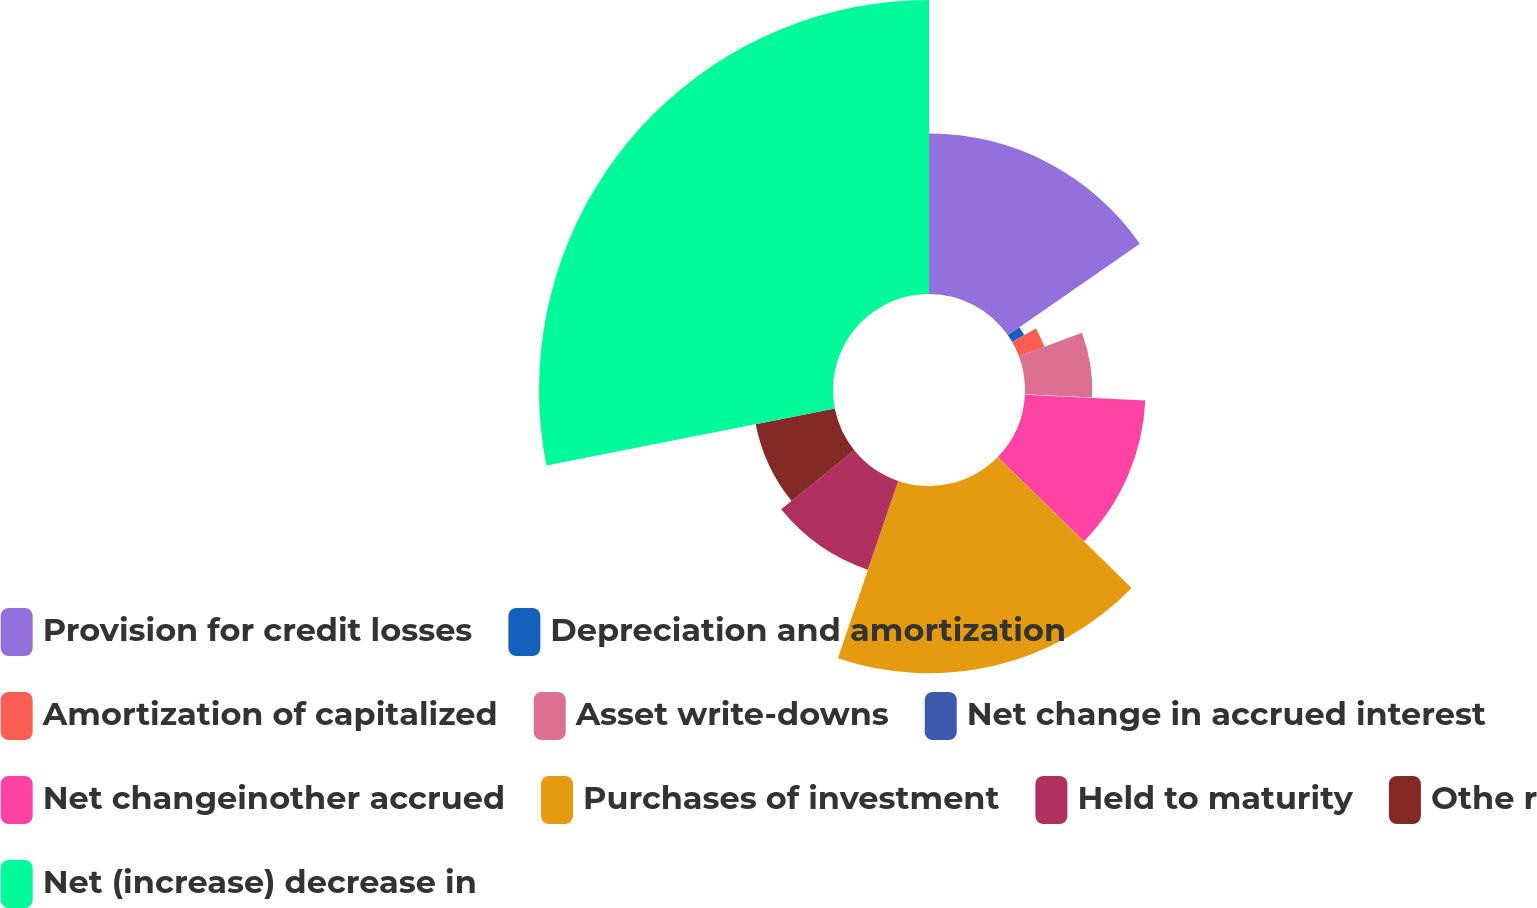Convert chart to OTSL. <chart><loc_0><loc_0><loc_500><loc_500><pie_chart><fcel>Provision for credit losses<fcel>Depreciation and amortization<fcel>Amortization of capitalized<fcel>Asset write-downs<fcel>Net change in accrued interest<fcel>Net changeinother accrued<fcel>Purchases of investment<fcel>Held to maturity<fcel>Othe r<fcel>Net (increase) decrease in<nl><fcel>15.35%<fcel>1.33%<fcel>2.61%<fcel>6.43%<fcel>0.06%<fcel>11.53%<fcel>17.9%<fcel>8.98%<fcel>7.71%<fcel>28.1%<nl></chart> 